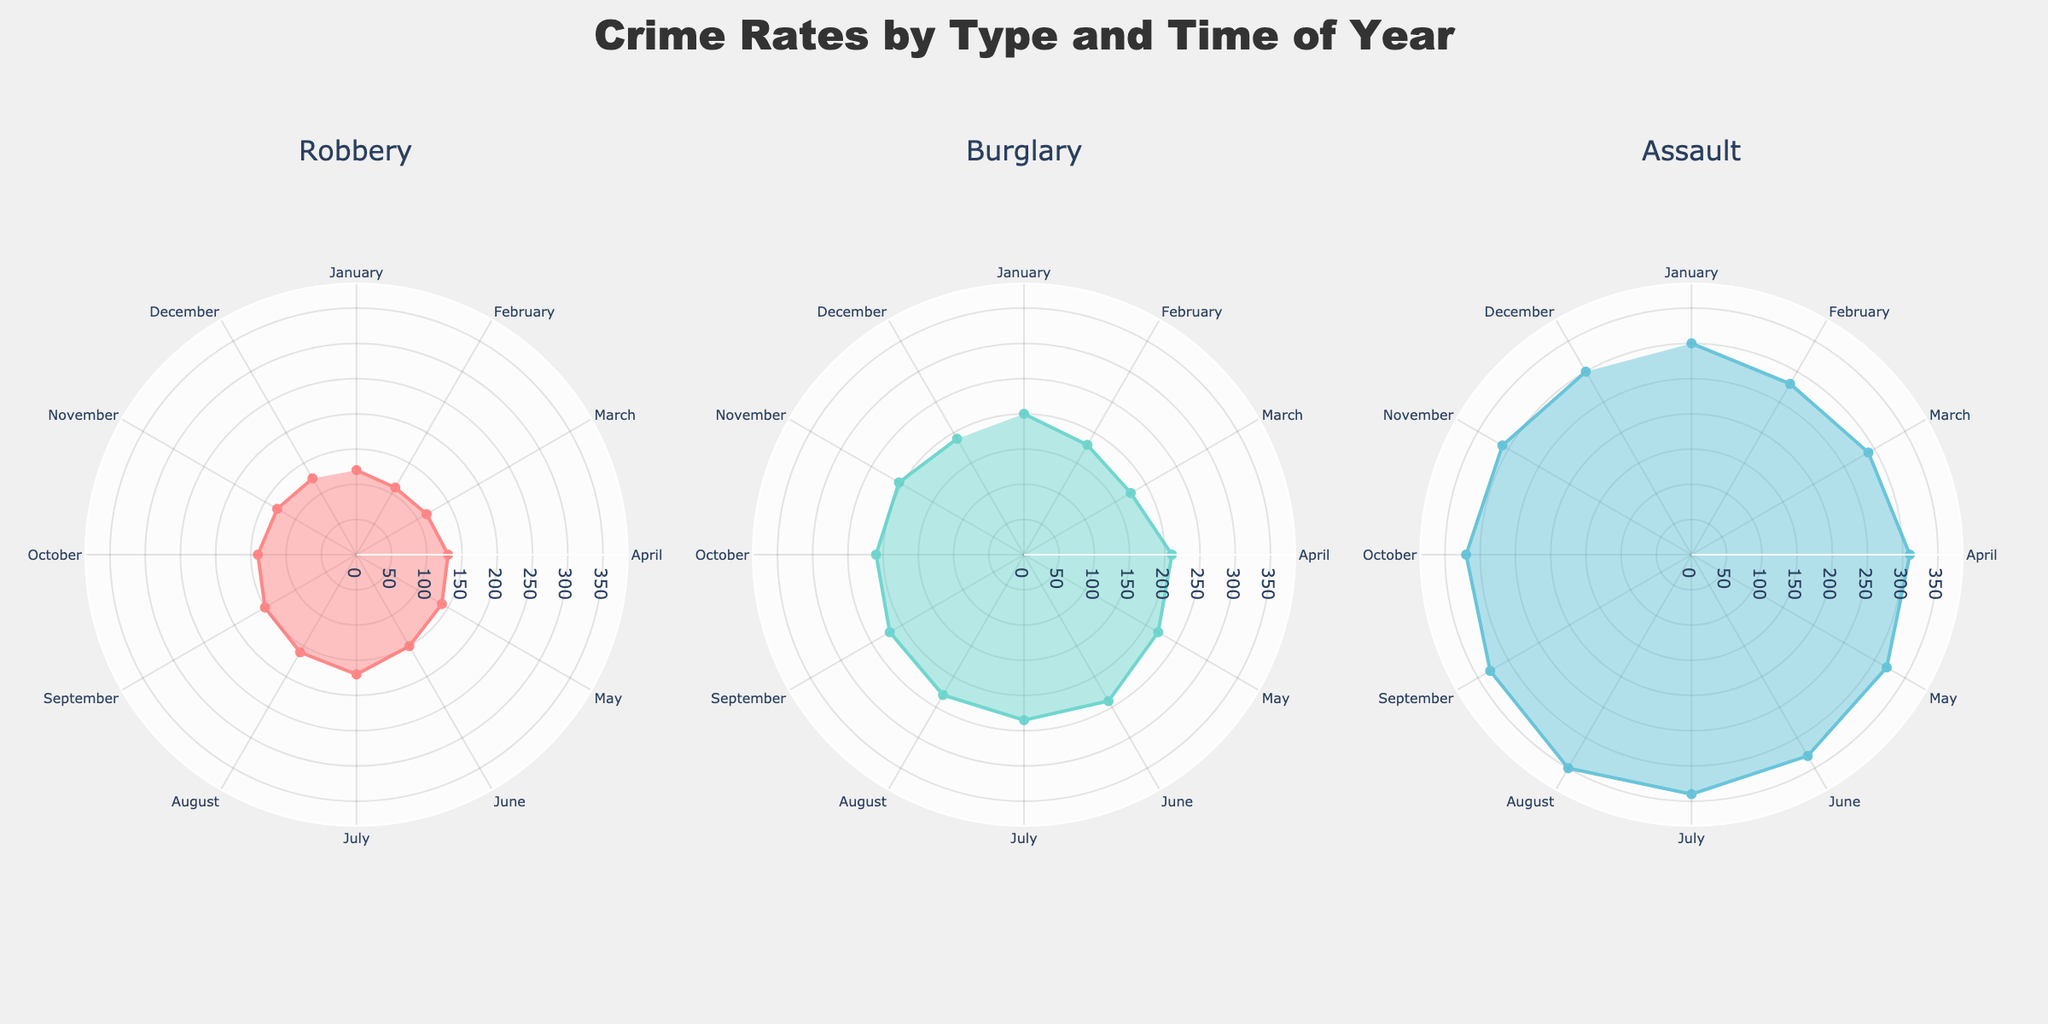Which month has the highest crime rate for Robbery? To find the highest crime rate for Robbery, identify the peak point on the polar chart corresponding to Robbery. The highest crime rate occurs in July with a rate of 170.
Answer: July What is the average crime rate for Burglary in the first quarter (January to March)? Add the crime rates for January (200), February (180), and March (175), then divide by 3 to find the average. (200 + 180 + 175) / 3 = 555 / 3 = 185.
Answer: 185 Which crime type shows the smallest variation throughout the year? Assess the fluctuation range for each crime type on the polar plots. Robbery shows the smallest variation as its crime rates fluctuate between 110 and 170.
Answer: Robbery During which month does Assault have the lowest crime rate? Locate the minimum point on the Assault polar chart. The lowest crime rate for Assault is in February, with a rate of 280.
Answer: February Compare the crime rates of Robbery and Burglary in June. Which one is higher, and by how much? Check the crime rates for both Robbery and Burglary in June. Robbery is 150, and Burglary is 240. The difference is 240 - 150 = 90.
Answer: Burglary is higher by 90 What's the total crime rate for all three types in December? Sum up the crime rates for all three types in December: Robbery (125), Burglary (190), and Assault (300). The total is 125 + 190 + 300 = 615.
Answer: 615 Which month shows the highest overall crime rate across all types? For each month, sum up the crime rates across all types and compare. July has the highest overall crime rate with Robbery (170), Burglary (235), and Assault (340), summing to 745.
Answer: July How does the crime rate for Robbery in August compare to that in September? The crime rate for Robbery in August is 160, and in September it is 150. August's rate is higher by 10 (160 - 150 = 10).
Answer: August is higher by 10 In which quarter does Burglary have the highest average crime rate? Average the crime rates for each quarter. The third quarter (July to September) has the highest average: (235 + 230 + 220) / 3 = 685 / 3 ≈ 228.3
Answer: Third quarter What is the difference between the highest and lowest crime rates for Assault? Find the highest rate (350 in August) and the lowest rate (280 in February). The difference is 350 - 280 = 70.
Answer: 70 